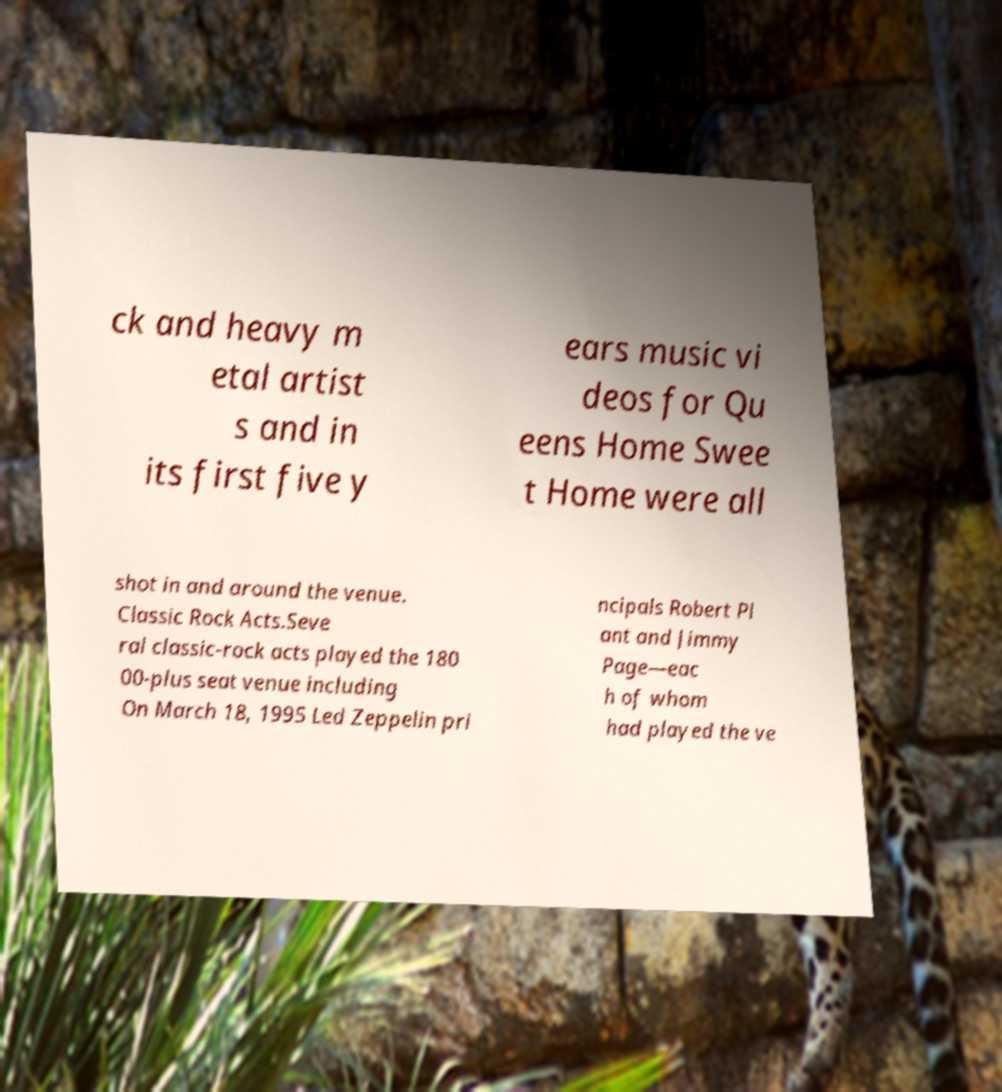Please read and relay the text visible in this image. What does it say? ck and heavy m etal artist s and in its first five y ears music vi deos for Qu eens Home Swee t Home were all shot in and around the venue. Classic Rock Acts.Seve ral classic-rock acts played the 180 00-plus seat venue including On March 18, 1995 Led Zeppelin pri ncipals Robert Pl ant and Jimmy Page—eac h of whom had played the ve 